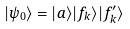Convert formula to latex. <formula><loc_0><loc_0><loc_500><loc_500>| \psi _ { 0 } \rangle = | a \rangle | f _ { k } \rangle | f _ { k } ^ { \prime } \rangle</formula> 